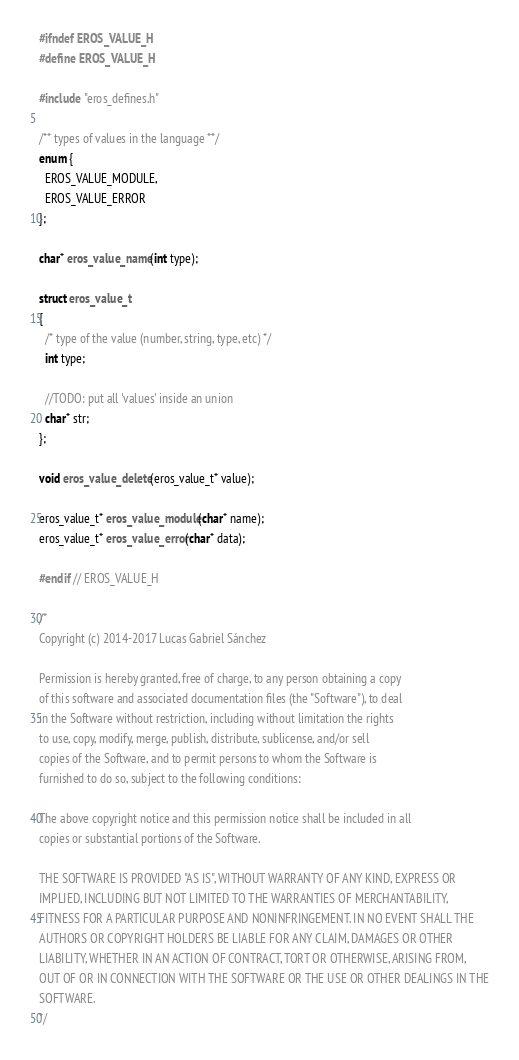Convert code to text. <code><loc_0><loc_0><loc_500><loc_500><_C_>#ifndef EROS_VALUE_H
#define EROS_VALUE_H

#include "eros_defines.h"

/** types of values in the language **/
enum {
  EROS_VALUE_MODULE,
  EROS_VALUE_ERROR
};

char* eros_value_name(int type);

struct eros_value_t
{
  /* type of the value (number, string, type, etc) */
  int type;

  //TODO: put all 'values' inside an union
  char* str;
};

void eros_value_delete(eros_value_t* value);

eros_value_t* eros_value_module(char* name);
eros_value_t* eros_value_error(char* data);

#endif // EROS_VALUE_H

/*
Copyright (c) 2014-2017 Lucas Gabriel Sánchez

Permission is hereby granted, free of charge, to any person obtaining a copy
of this software and associated documentation files (the "Software"), to deal
in the Software without restriction, including without limitation the rights
to use, copy, modify, merge, publish, distribute, sublicense, and/or sell
copies of the Software, and to permit persons to whom the Software is
furnished to do so, subject to the following conditions:

The above copyright notice and this permission notice shall be included in all
copies or substantial portions of the Software.

THE SOFTWARE IS PROVIDED "AS IS", WITHOUT WARRANTY OF ANY KIND, EXPRESS OR
IMPLIED, INCLUDING BUT NOT LIMITED TO THE WARRANTIES OF MERCHANTABILITY,
FITNESS FOR A PARTICULAR PURPOSE AND NONINFRINGEMENT. IN NO EVENT SHALL THE
AUTHORS OR COPYRIGHT HOLDERS BE LIABLE FOR ANY CLAIM, DAMAGES OR OTHER
LIABILITY, WHETHER IN AN ACTION OF CONTRACT, TORT OR OTHERWISE, ARISING FROM,
OUT OF OR IN CONNECTION WITH THE SOFTWARE OR THE USE OR OTHER DEALINGS IN THE
SOFTWARE.
*/

</code> 